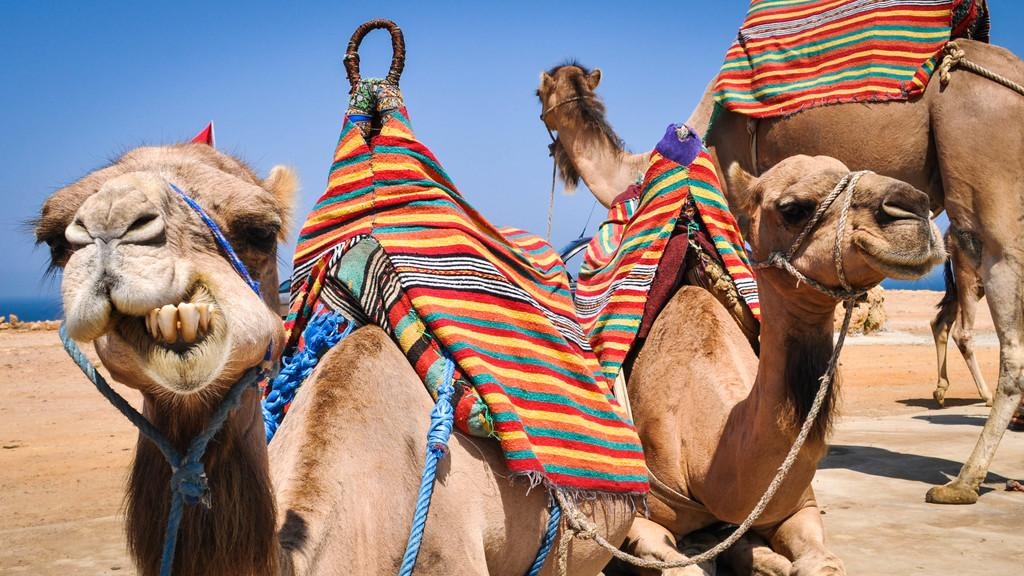What animals are present in the image? There are camels in the image. What are the positions of the camels in the image? Some camels are sitting, while others are standing. What is covering the camels? Clothes are visible on the camels. What type of surface is visible in the image? There is ground visible in the image. What can be seen in the sky in the background of the image? There are clouds in the sky in the background of the image. What type of cable can be seen connecting the camels in the image? There is no cable connecting the camels in the image. What type of structure is visible in the background of the image? There is no structure visible in the background of the image; only clouds in the sky can be seen. 